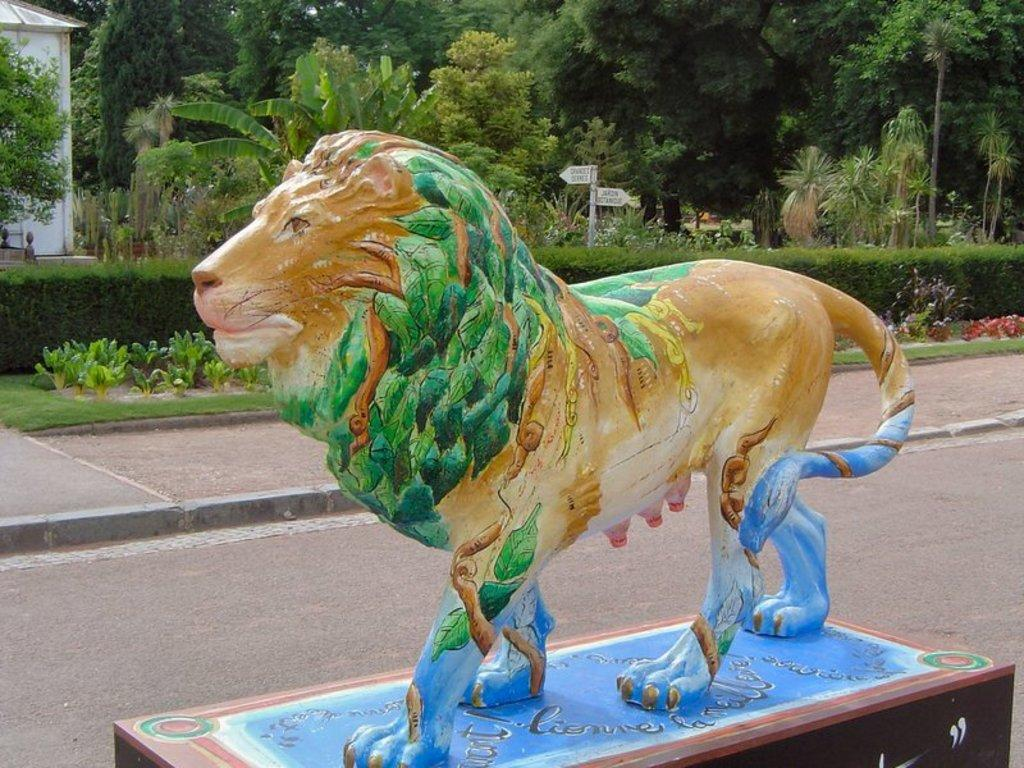What is the main subject in the image? There is a statue in the image. What type of vegetation can be seen in the image? There are plants, trees, and grass visible in the image. Are there any signs or messages in the image? Yes, there are boards with text in the image. What type of structure is visible in the image? There is a house visible in the image. What type of wool is being used to make the hat in the image? There is no hat present in the image, so it is not possible to determine the type of wool being used. 